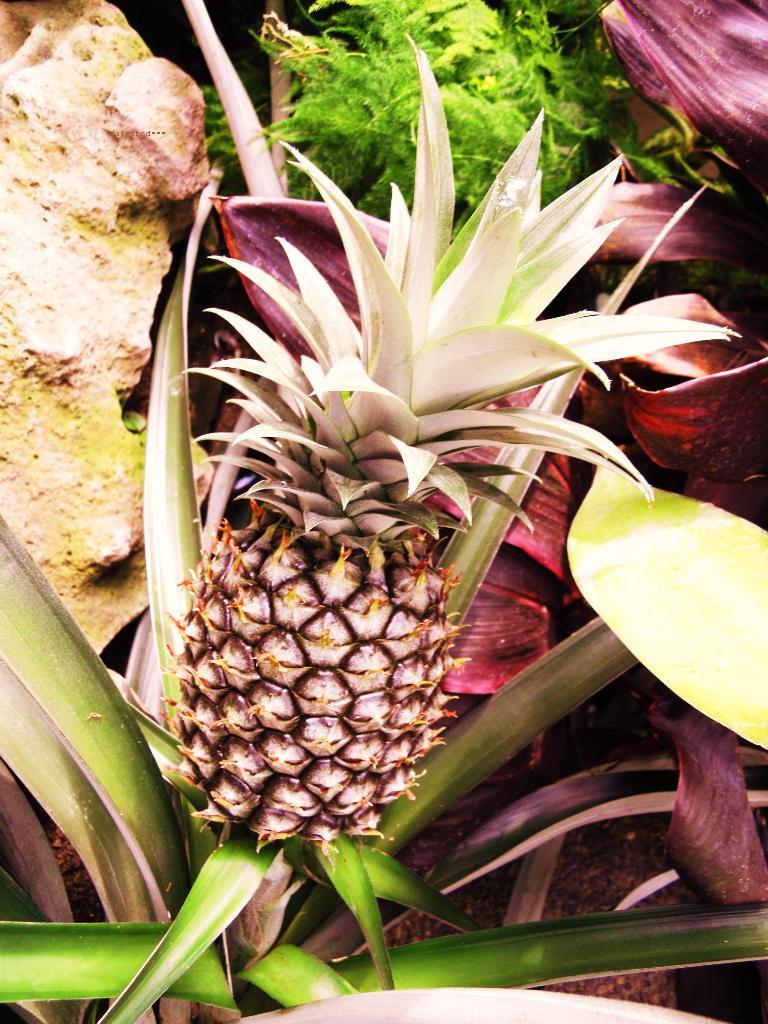Describe this image in one or two sentences. We can see pineapple, plant, leaves and rock. 